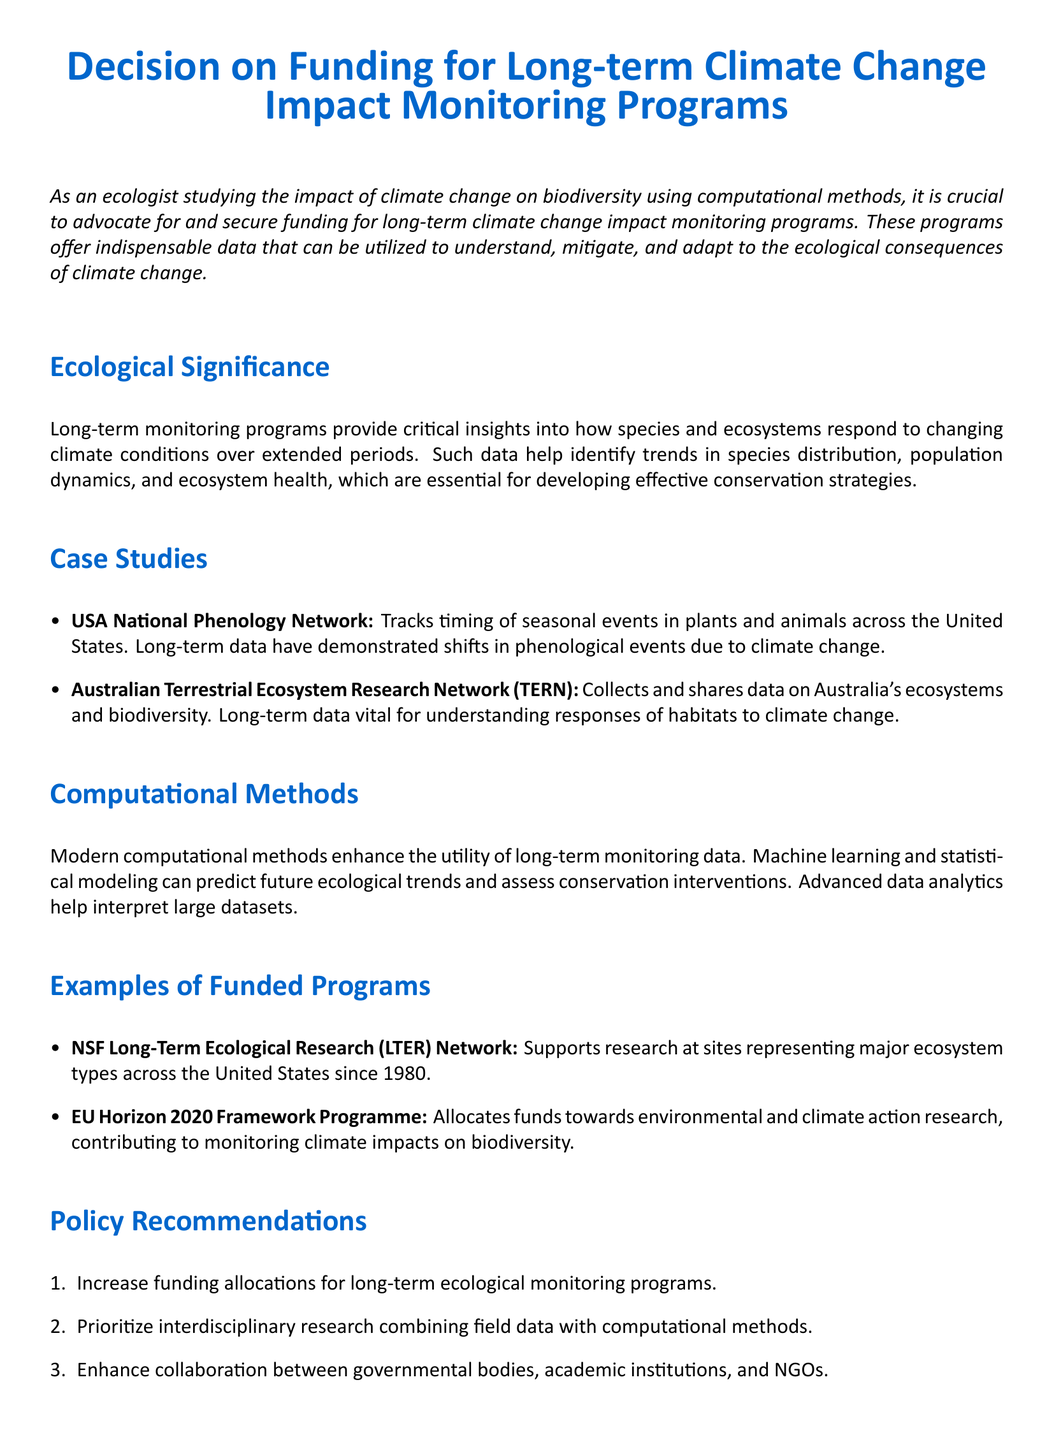What is the title of the document? The title is clearly stated at the beginning of the document and identifies the subject it covers.
Answer: Decision on Funding for Long-term Climate Change Impact Monitoring Programs What program is mentioned for tracking seasonal events? The document lists a specific program known for its focus on phenological events in plants and animals, illustrating its relevance to climate change impacts.
Answer: USA National Phenology Network When was the NSF Long-Term Ecological Research Network established? This information is directly provided in the section discussing examples of funded programs, indicating how long it has been supporting ecological research.
Answer: 1980 What is one of the goals of long-term monitoring programs? The document highlights a significant objective for these programs, emphasizing their role in understanding ecological responses to climate change.
Answer: Identify trends in species distribution What does TERN stand for? The document mentions this acronym, which refers to a specific network focused on Australia's ecosystems and biodiversity, relevant to climate research.
Answer: Australian Terrestrial Ecosystem Research Network What is one recommended policy for climate change monitoring? The policy recommendations section outlines specific actions that could be taken to enhance monitoring efforts, directly addressing funding needs.
Answer: Increase funding allocations What are modern methods used to analyze long-term monitoring data? This question addresses the section on computational methods, describing advanced techniques that improve data utility for ecological research.
Answer: Machine learning and statistical modeling What is the goal of the EU Horizon 2020 Framework Programme? The document describes a specific focus of this program concerning environmental and climate action, emphasizing its funding contributions.
Answer: Monitoring climate impacts on biodiversity 